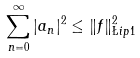Convert formula to latex. <formula><loc_0><loc_0><loc_500><loc_500>\sum _ { n = 0 } ^ { \infty } | a _ { n } | ^ { 2 } \leq \| f \| _ { \L i p 1 } ^ { 2 }</formula> 